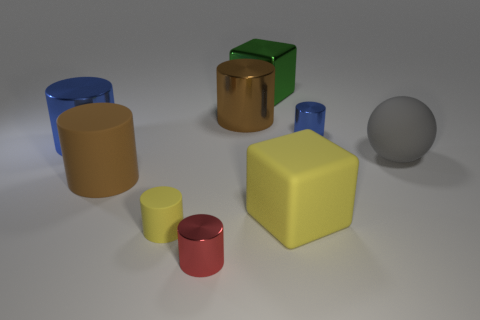Subtract all red cylinders. How many cylinders are left? 5 Subtract all red shiny cylinders. How many cylinders are left? 5 Subtract all cyan cylinders. Subtract all blue balls. How many cylinders are left? 6 Subtract all cubes. How many objects are left? 7 Add 2 blue objects. How many blue objects exist? 4 Subtract 0 cyan spheres. How many objects are left? 9 Subtract all small blue metal things. Subtract all big blue metal cylinders. How many objects are left? 7 Add 4 brown metallic things. How many brown metallic things are left? 5 